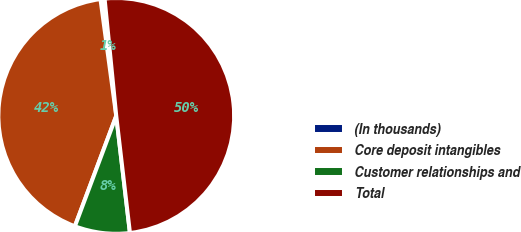Convert chart. <chart><loc_0><loc_0><loc_500><loc_500><pie_chart><fcel>(In thousands)<fcel>Core deposit intangibles<fcel>Customer relationships and<fcel>Total<nl><fcel>0.56%<fcel>42.16%<fcel>7.56%<fcel>49.72%<nl></chart> 